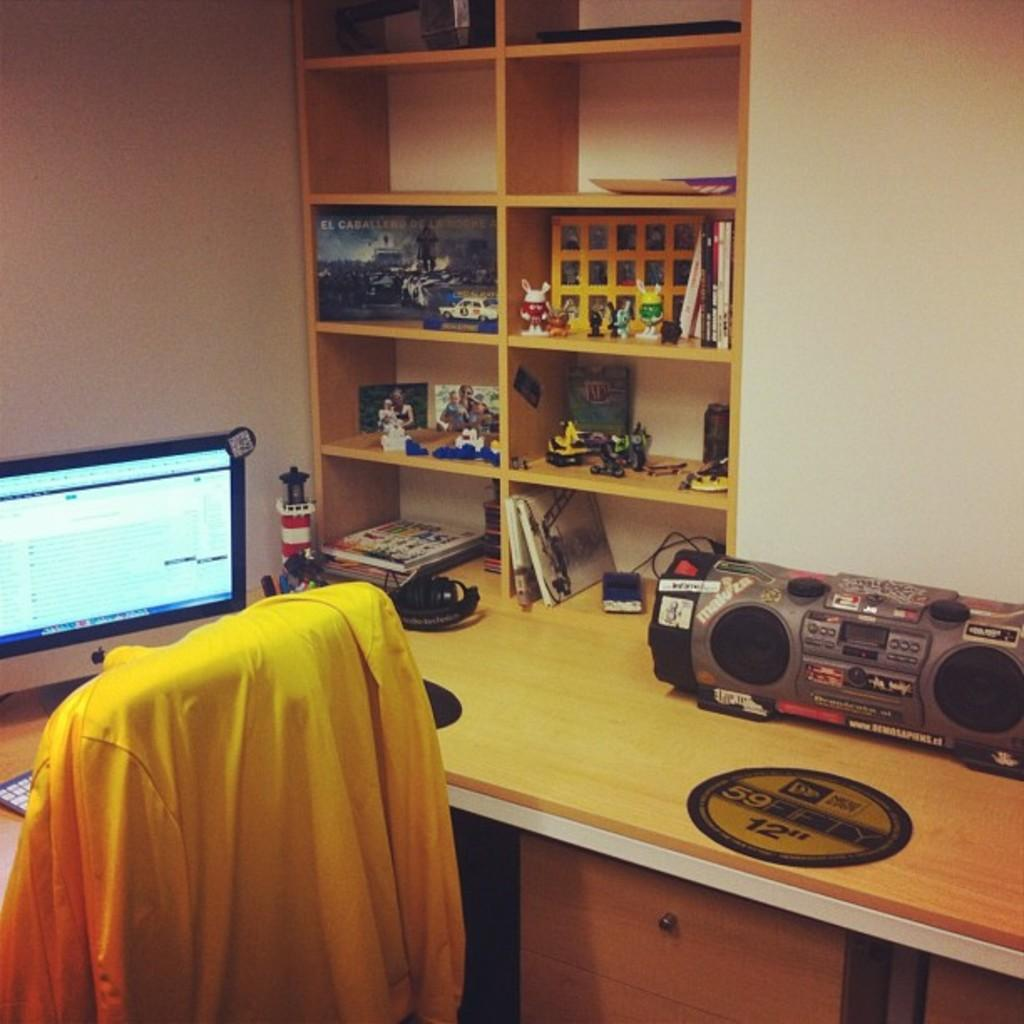What electronic device is visible in the image? There is a monitor in the image. What is located on the table in the image? There is a music player on a table in the image. What can be seen on a shelf in the image? There are items on a shelf in the image. How many boys are present in the image? There is no mention of boys or any people in the image; it only features a monitor, a music player, and items on a shelf. 